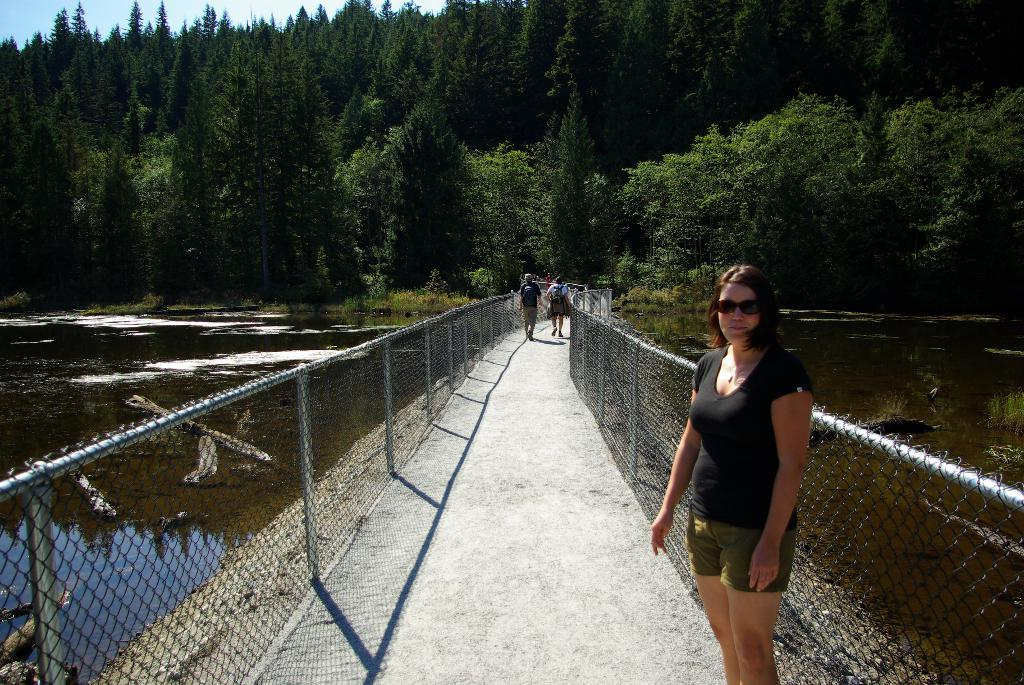What can be seen running through the image? There is a path in the image. What is happening on the path? There are people standing on the path. What type of barrier is present in the image? There is fencing in the image. What can be observed in relation to the people and the path? Shadows are visible in the image. What natural element is present in the image? There is water in the image. What can be seen in the distance in the image? There are trees in the background of the image. What is visible above the trees in the image? The sky is visible in the background of the image. What type of volleyball game is being played on the path in the image? There is no volleyball game present in the image; it features a path with people standing on it. How does the nerve affect the shadows in the image? There is no mention of a nerve in the image, and shadows are not affected by nerves; they are formed by the interaction of light and objects. 